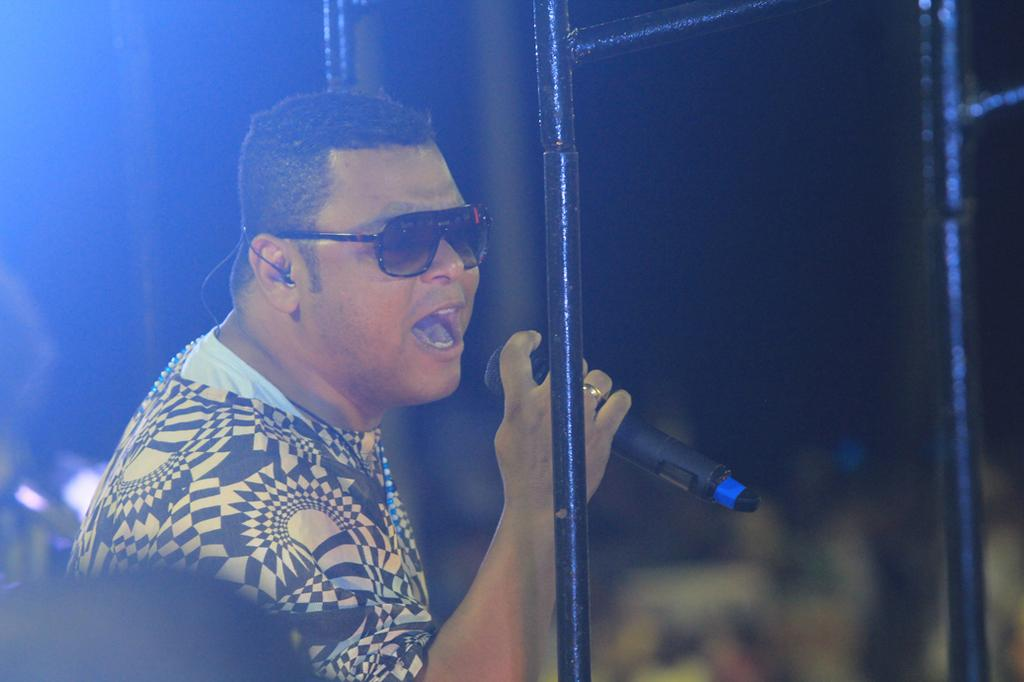What is the main subject of the image? There is a man in the image. What is the man holding in the image? The man is holding a microphone. Can you describe the man's appearance? The man is wearing glasses. What else can be seen in the image besides the man? There are rods visible in the image. How would you describe the background of the image? The background of the image is dark and blurry. Can you tell me where the stream is located in the image? There is no stream present in the image. What type of tub is visible in the image? There is no tub present in the image. 